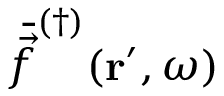<formula> <loc_0><loc_0><loc_500><loc_500>\bar { \vec { f } } ^ { ( \dagger ) } ( r ^ { \prime } , \omega )</formula> 